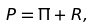<formula> <loc_0><loc_0><loc_500><loc_500>P = \Pi + R ,</formula> 